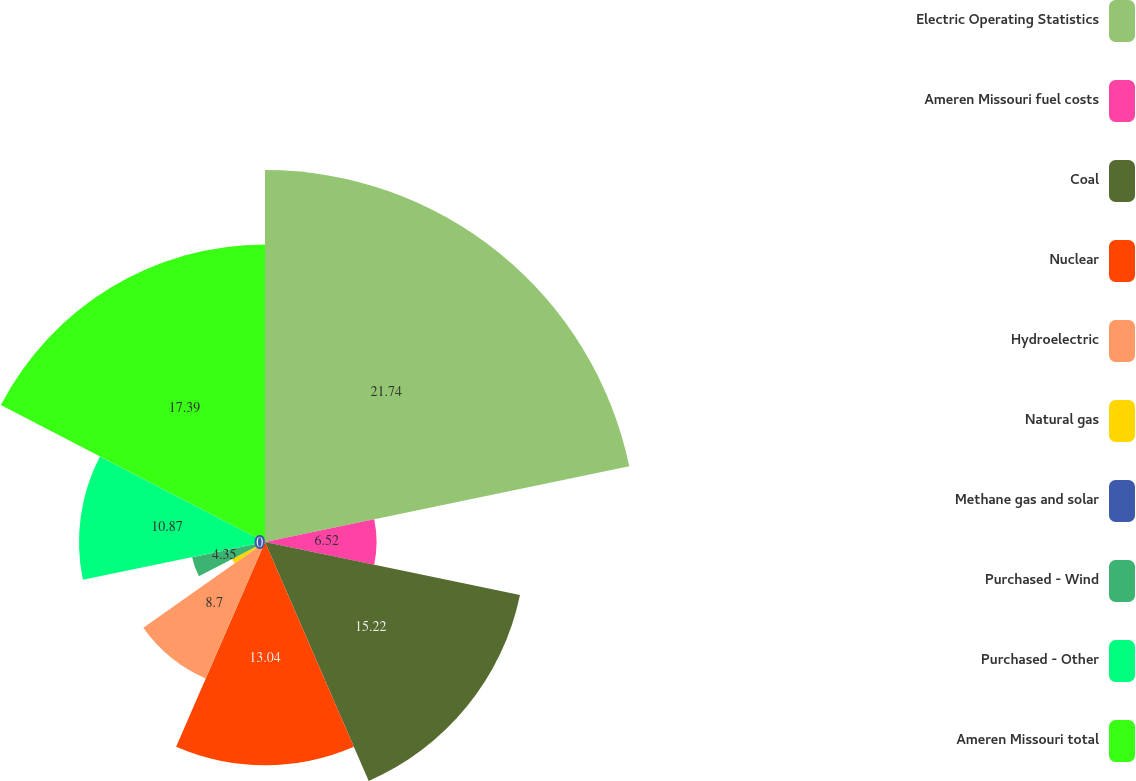Convert chart to OTSL. <chart><loc_0><loc_0><loc_500><loc_500><pie_chart><fcel>Electric Operating Statistics<fcel>Ameren Missouri fuel costs<fcel>Coal<fcel>Nuclear<fcel>Hydroelectric<fcel>Natural gas<fcel>Methane gas and solar<fcel>Purchased - Wind<fcel>Purchased - Other<fcel>Ameren Missouri total<nl><fcel>21.74%<fcel>6.52%<fcel>15.22%<fcel>13.04%<fcel>8.7%<fcel>2.17%<fcel>0.0%<fcel>4.35%<fcel>10.87%<fcel>17.39%<nl></chart> 